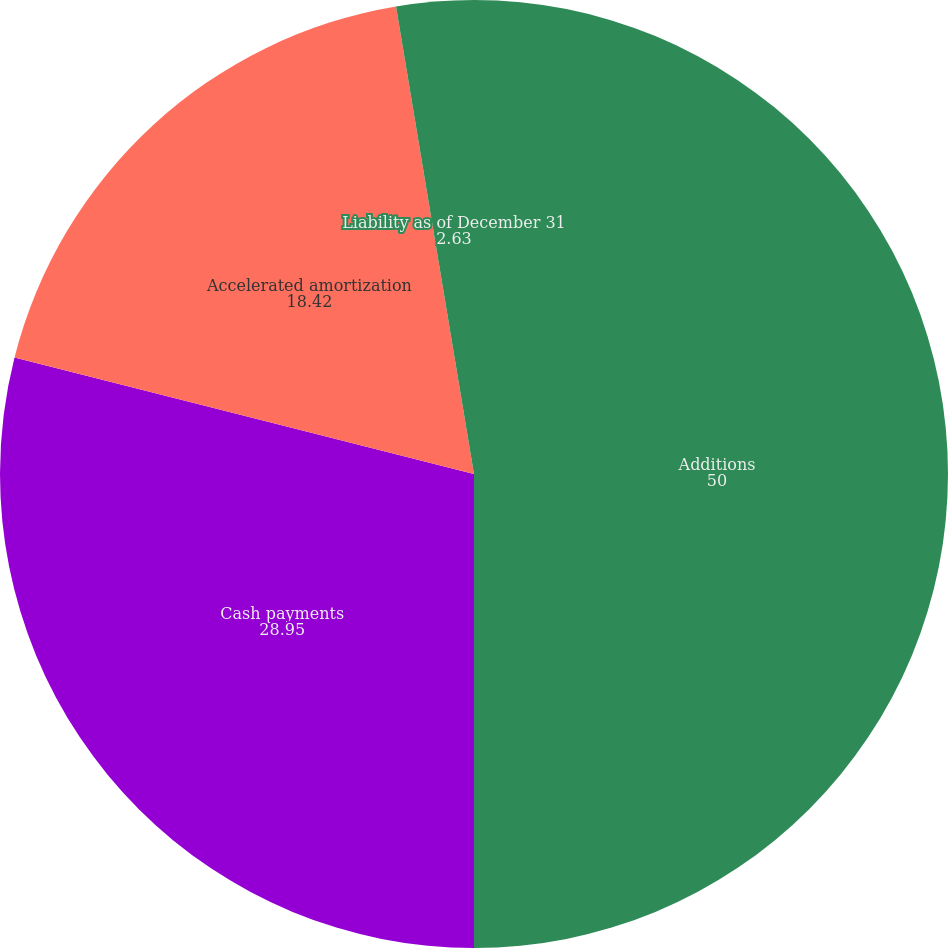Convert chart. <chart><loc_0><loc_0><loc_500><loc_500><pie_chart><fcel>Additions<fcel>Cash payments<fcel>Accelerated amortization<fcel>Liability as of December 31<nl><fcel>50.0%<fcel>28.95%<fcel>18.42%<fcel>2.63%<nl></chart> 